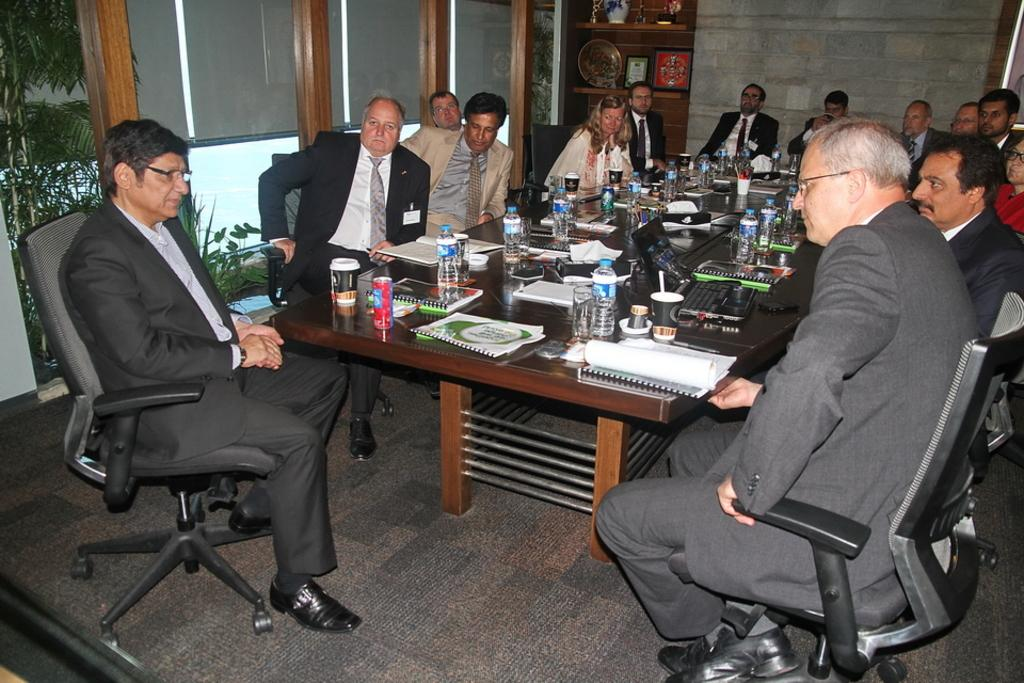What are the people in the image doing? The people in the image are sitting on chairs. What objects can be seen on the table in the image? There is a laptop on a table in the image. What type of containers are present in the image? There are bottles and glasses in the image. What can be seen in the background of the image? There is a glass door, a tree, and a wall in the background of the image. How many cherries are on the laptop in the image? There are no cherries present in the image, and the laptop is not mentioned as having any cherries on it. 